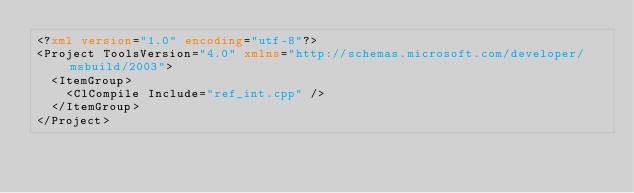Convert code to text. <code><loc_0><loc_0><loc_500><loc_500><_XML_><?xml version="1.0" encoding="utf-8"?>
<Project ToolsVersion="4.0" xmlns="http://schemas.microsoft.com/developer/msbuild/2003">
  <ItemGroup>
    <ClCompile Include="ref_int.cpp" />
  </ItemGroup>
</Project>
</code> 